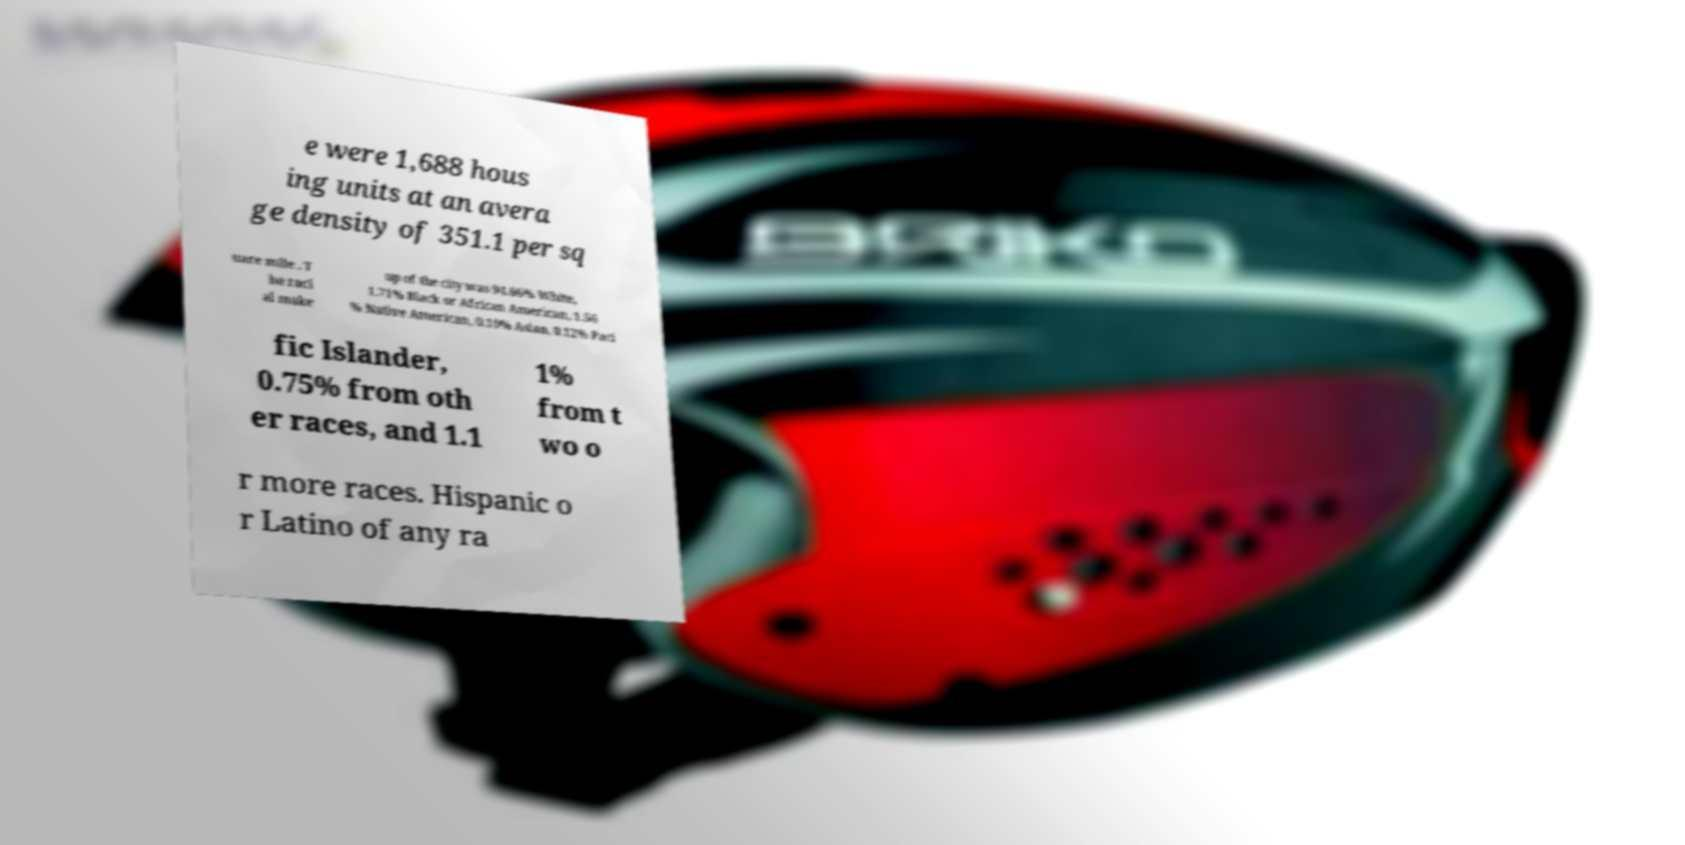Can you accurately transcribe the text from the provided image for me? e were 1,688 hous ing units at an avera ge density of 351.1 per sq uare mile . T he raci al make up of the city was 94.66% White, 1.71% Black or African American, 1.56 % Native American, 0.10% Asian, 0.12% Paci fic Islander, 0.75% from oth er races, and 1.1 1% from t wo o r more races. Hispanic o r Latino of any ra 